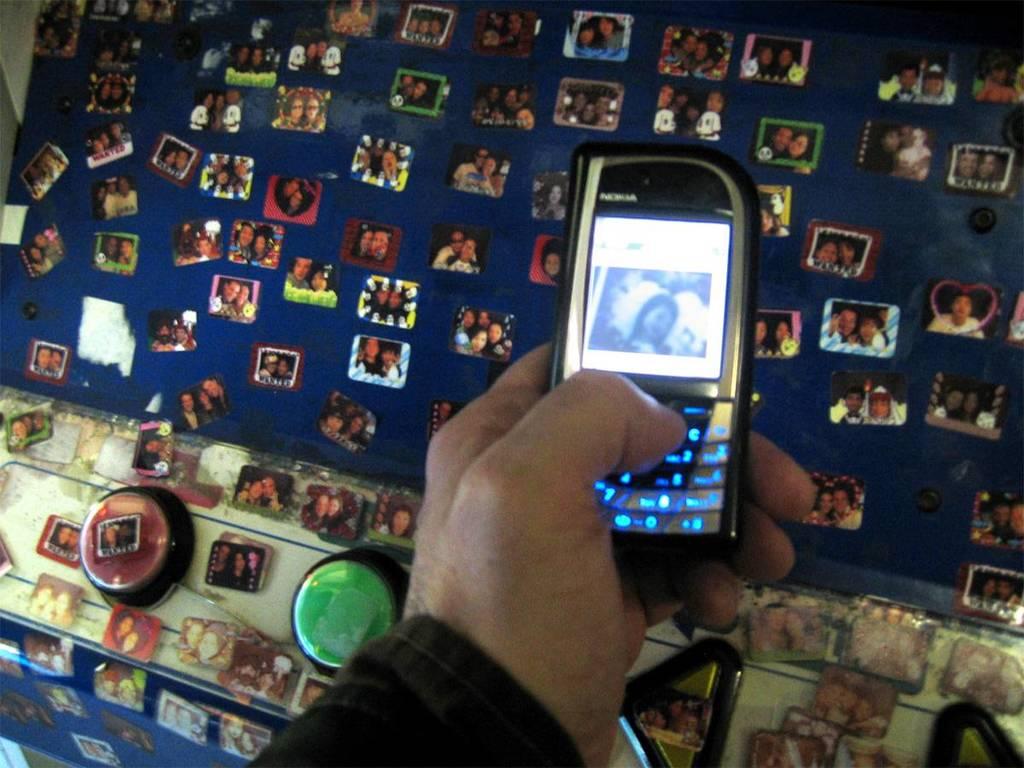What brand created this cell phone?
Make the answer very short. Nokia. 